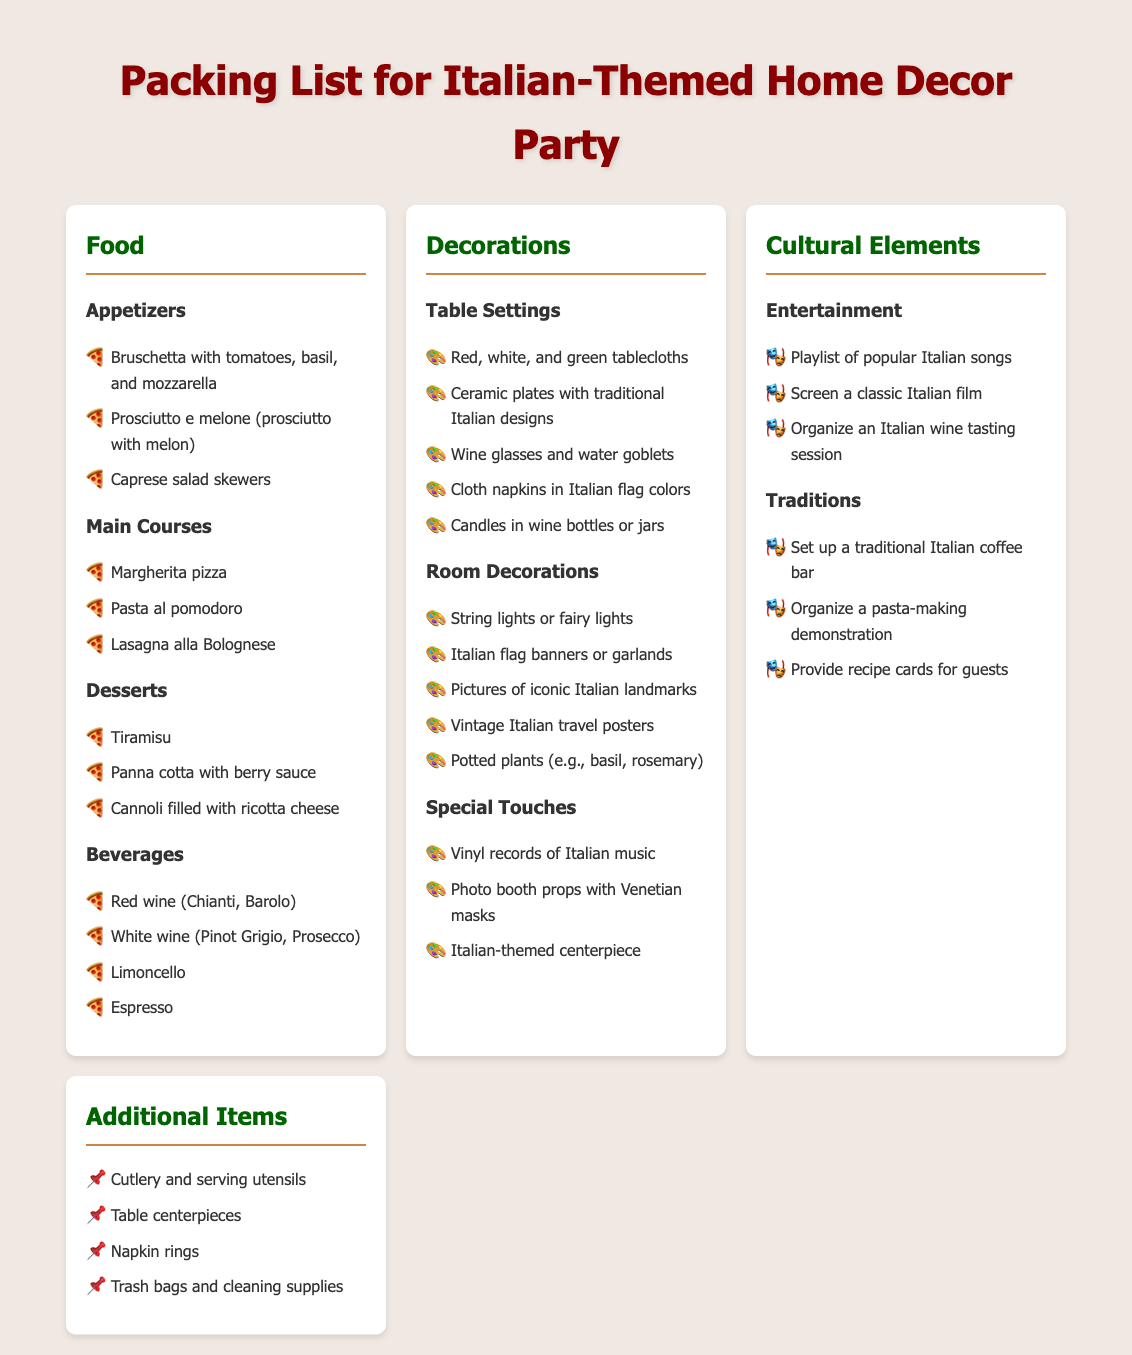What are three appetizers listed? The document provides three appetizers in the food section: Bruschetta with tomatoes, basil, and mozzarella; Prosciutto e melone; and Caprese salad skewers.
Answer: Bruschetta, Prosciutto e melone, Caprese salad skewers How many main courses are there? The document outlines three main courses in the food section: Margherita pizza, Pasta al pomodoro, and Lasagna alla Bolognese, making a total of three.
Answer: 3 What types of wines are included in beverages? The document specifies red wine (Chianti, Barolo) and white wine (Pinot Grigio, Prosecco) as part of the beverages.
Answer: Red and white wine What cultural element involves a film? The document mentions that screening a classic Italian film is part of the entertainment in the cultural elements section.
Answer: Classic Italian film What is a special decoration touch mentioned? The document lists vinyl records of Italian music as one of the special touches you can use for decorations.
Answer: Vinyl records of Italian music How many porposed desserts are there? The document includes three desserts: Tiramisu, Panna cotta with berry sauce, and Cannoli filled with ricotta cheese.
Answer: 3 What colors are suggested for napkins? The document states that cloth napkins in Italian flag colors should be used for table settings.
Answer: Italian flag colors What type of decoration includes potted plants? The document specifies that potted plants, such as basil and rosemary, are part of the room decorations section.
Answer: Room decorations 